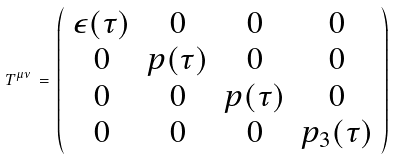Convert formula to latex. <formula><loc_0><loc_0><loc_500><loc_500>T ^ { \mu \nu } \, = \, \left ( \begin{array} { c c c c } \epsilon ( \tau ) & 0 & 0 & 0 \\ 0 & p ( \tau ) & 0 & 0 \\ 0 & 0 & p ( \tau ) & 0 \\ 0 & 0 & 0 & p _ { 3 } ( \tau ) \end{array} \right )</formula> 